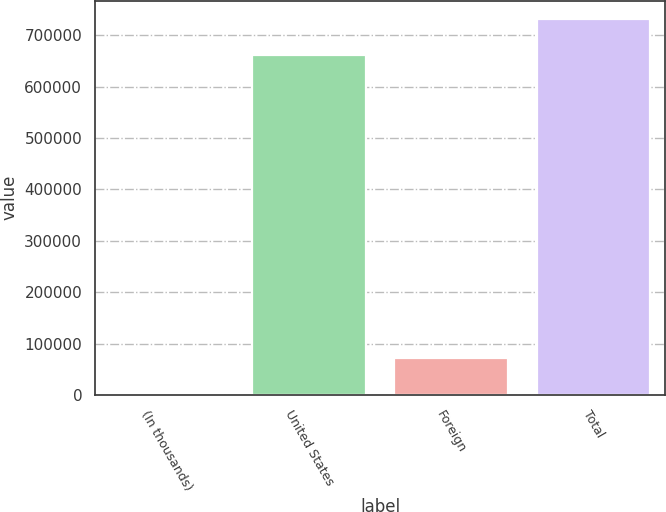Convert chart to OTSL. <chart><loc_0><loc_0><loc_500><loc_500><bar_chart><fcel>(In thousands)<fcel>United States<fcel>Foreign<fcel>Total<nl><fcel>2007<fcel>661966<fcel>71447.5<fcel>731406<nl></chart> 